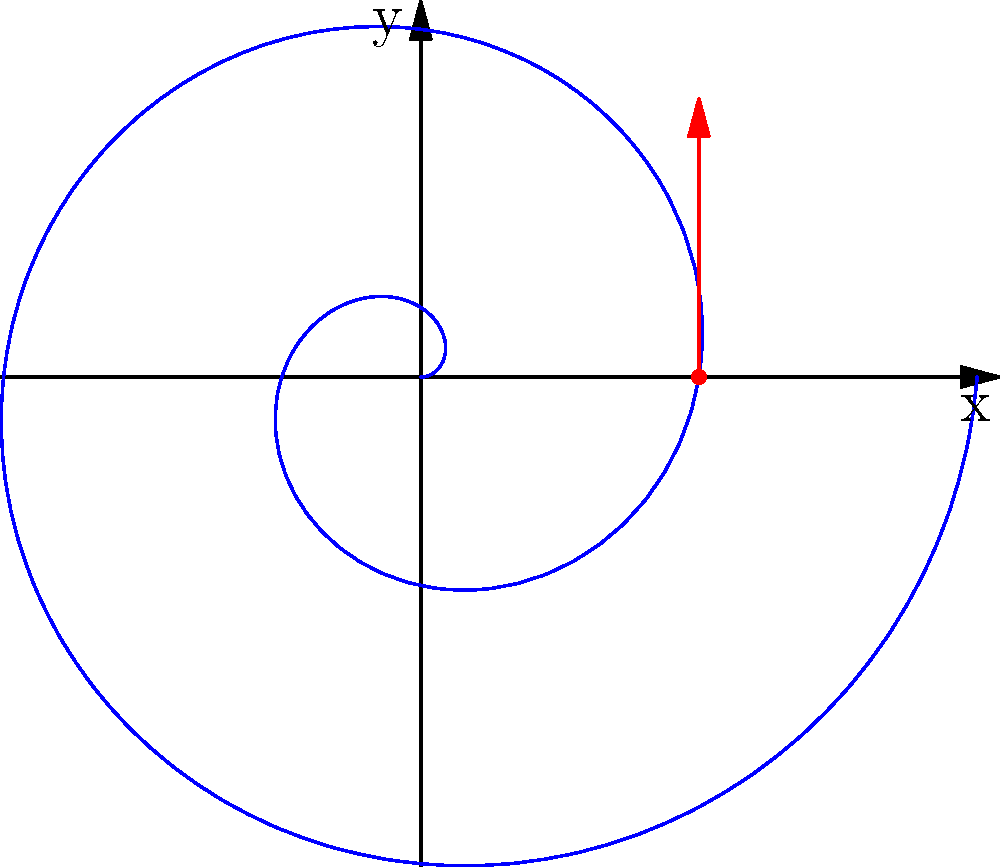A vinyl record's groove is modeled by the spiral curve $r = 0.1t$ in polar coordinates. At the point where $t = 2\pi$, find the slope of the tangent line to this curve in Cartesian coordinates. To solve this problem, we'll follow these steps:

1) First, we need to convert the polar equation to parametric form:
   $x = r\cos(t) = 0.1t\cos(t)$
   $y = r\sin(t) = 0.1t\sin(t)$

2) To find the slope of the tangent line, we need to calculate $\frac{dy}{dx}$ at $t = 2\pi$. We can do this using the chain rule:

   $\frac{dy}{dx} = \frac{dy/dt}{dx/dt}$

3) Let's calculate $\frac{dx}{dt}$ and $\frac{dy}{dt}$:
   
   $\frac{dx}{dt} = 0.1\cos(t) - 0.1t\sin(t)$
   $\frac{dy}{dt} = 0.1\sin(t) + 0.1t\cos(t)$

4) Now, let's evaluate these at $t = 2\pi$:
   
   $\frac{dx}{dt}|_{t=2\pi} = 0.1\cos(2\pi) - 0.1(2\pi)\sin(2\pi) = 0.1$
   $\frac{dy}{dt}|_{t=2\pi} = 0.1\sin(2\pi) + 0.1(2\pi)\cos(2\pi) = 0.2\pi$

5) Therefore, the slope of the tangent line at $t = 2\pi$ is:

   $\frac{dy}{dx}|_{t=2\pi} = \frac{0.2\pi}{0.1} = 2\pi$
Answer: $2\pi$ 